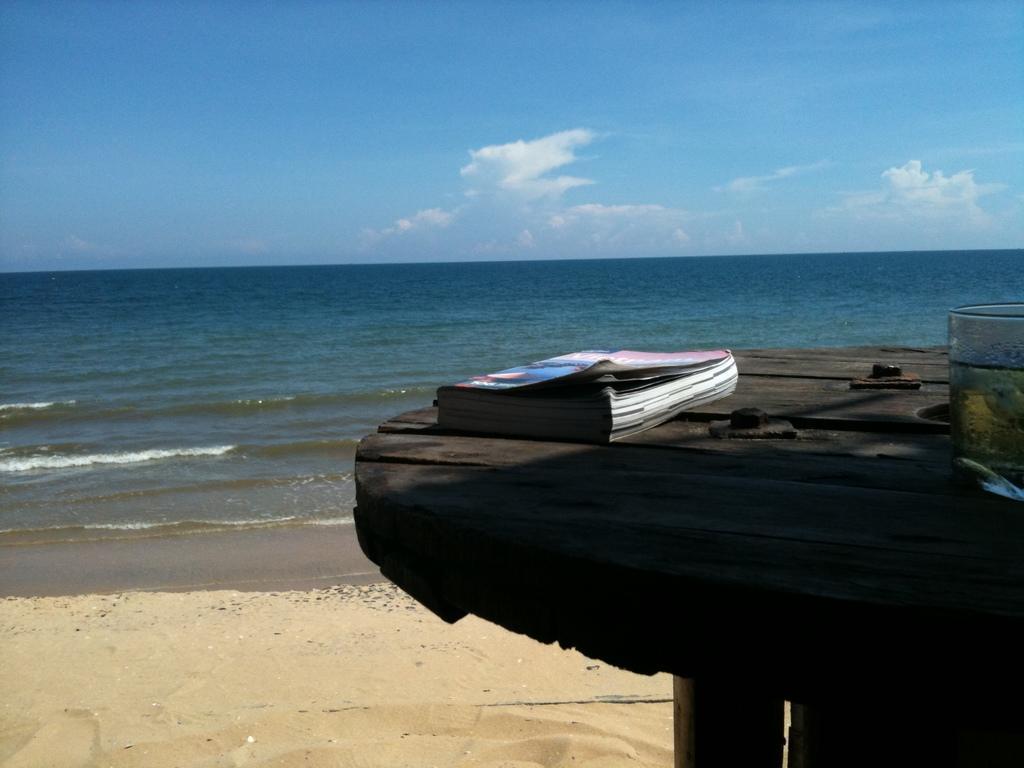How would you summarize this image in a sentence or two? Here we can see a book and a glass with liquid and a slice in it on a table. In the background we can see sand,water and clouds in the sky. 